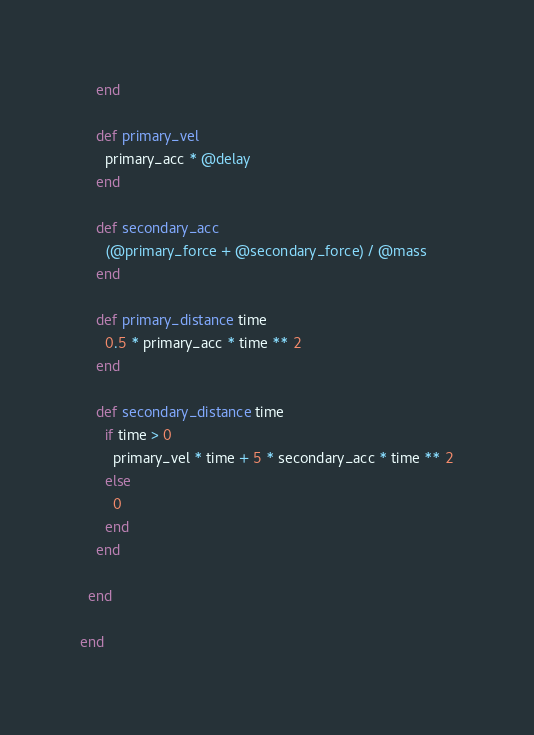<code> <loc_0><loc_0><loc_500><loc_500><_Ruby_>    end

    def primary_vel
      primary_acc * @delay
    end

    def secondary_acc
      (@primary_force + @secondary_force) / @mass
    end

    def primary_distance time
      0.5 * primary_acc * time ** 2
    end

    def secondary_distance time
      if time > 0
        primary_vel * time + 5 * secondary_acc * time ** 2
      else
        0
      end
    end

  end

end
</code> 